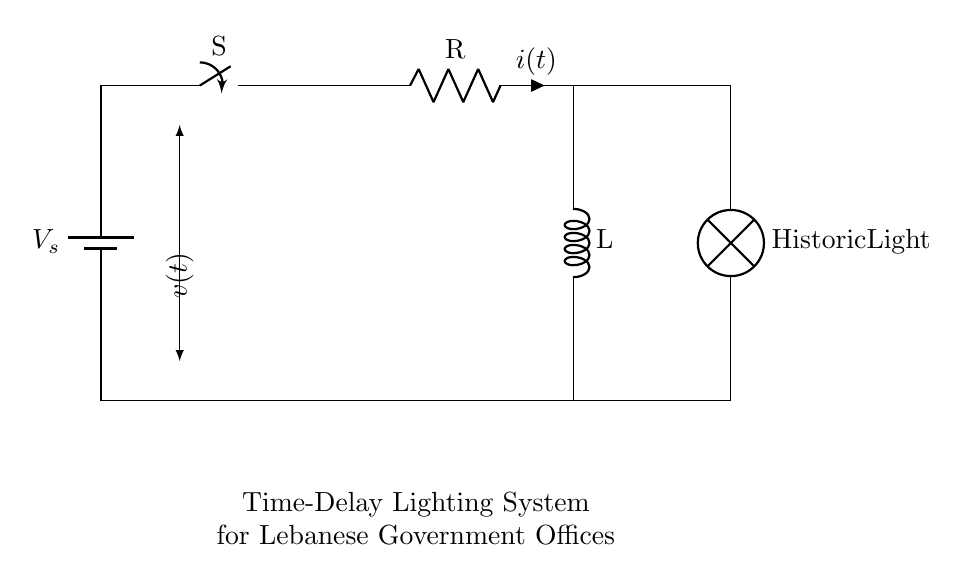What is the voltage source in the circuit? The voltage source is denoted by V_s, which is represented as a battery in the circuit diagram.
Answer: V_s What is the main purpose of the switch in this circuit? The switch, labeled S, controls the flow of current by opening or closing the circuit, allowing or preventing the voltage from reaching the load (lamp).
Answer: Control current What components are included in this RL circuit? The components include a resistor (R), an inductor (L), a direct current voltage source (V_s), and a lamp (Historic Light).
Answer: Resistor, inductor, battery, lamp What is the effect of adding an inductor to the circuit? The inductor L creates a delay in the current flow when the switch is closed, due to its property of resisting changes in current, which helps in managing the timing for the lighting system.
Answer: Creates delay How does the resistor value affect the time delay? Increasing the resistance (R) will result in a higher time constant (τ = L/R), meaning the light will take longer to reach full brightness after the switch is turned on.
Answer: Increases delay What is the expected behavior of the lamp when the switch opens? When the switch opens, the current flow will stop, and the lamp will turn off gradually due to the energy stored in the inductor being released, leading to a slower dimming of the light.
Answer: Gradual dimming 